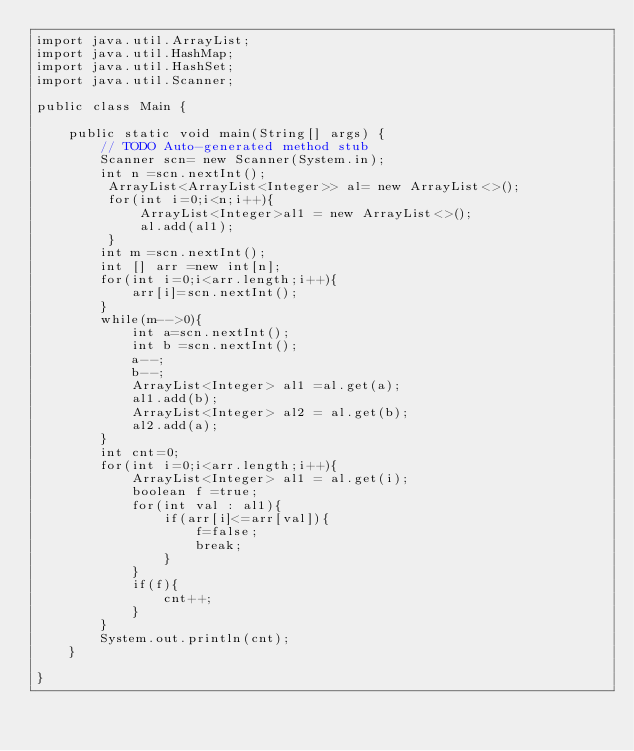Convert code to text. <code><loc_0><loc_0><loc_500><loc_500><_Java_>import java.util.ArrayList;
import java.util.HashMap;
import java.util.HashSet;
import java.util.Scanner;

public class Main {

	public static void main(String[] args) {
		// TODO Auto-generated method stub
		Scanner scn= new Scanner(System.in);
		int n =scn.nextInt();
		 ArrayList<ArrayList<Integer>> al= new ArrayList<>();
		 for(int i=0;i<n;i++){
			 ArrayList<Integer>al1 = new ArrayList<>();
			 al.add(al1);
		 }
		int m =scn.nextInt();
		int [] arr =new int[n];
		for(int i=0;i<arr.length;i++){
			arr[i]=scn.nextInt();
		}
		while(m-->0){
			int a=scn.nextInt();
			int b =scn.nextInt();
			a--;
			b--;
			ArrayList<Integer> al1 =al.get(a);
			al1.add(b);
			ArrayList<Integer> al2 = al.get(b);
			al2.add(a);
		}
		int cnt=0;
		for(int i=0;i<arr.length;i++){
			ArrayList<Integer> al1 = al.get(i);
			boolean f =true;
			for(int val : al1){
				if(arr[i]<=arr[val]){
					f=false;
					break;
				}
			}
			if(f){
				cnt++;
			}
		}
		System.out.println(cnt);
	}

}</code> 